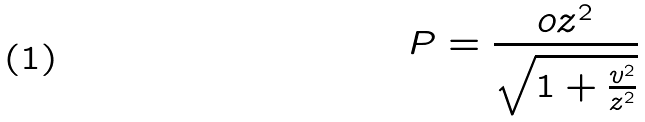Convert formula to latex. <formula><loc_0><loc_0><loc_500><loc_500>P = \frac { o z ^ { 2 } } { \sqrt { 1 + \frac { v ^ { 2 } } { z ^ { 2 } } } }</formula> 